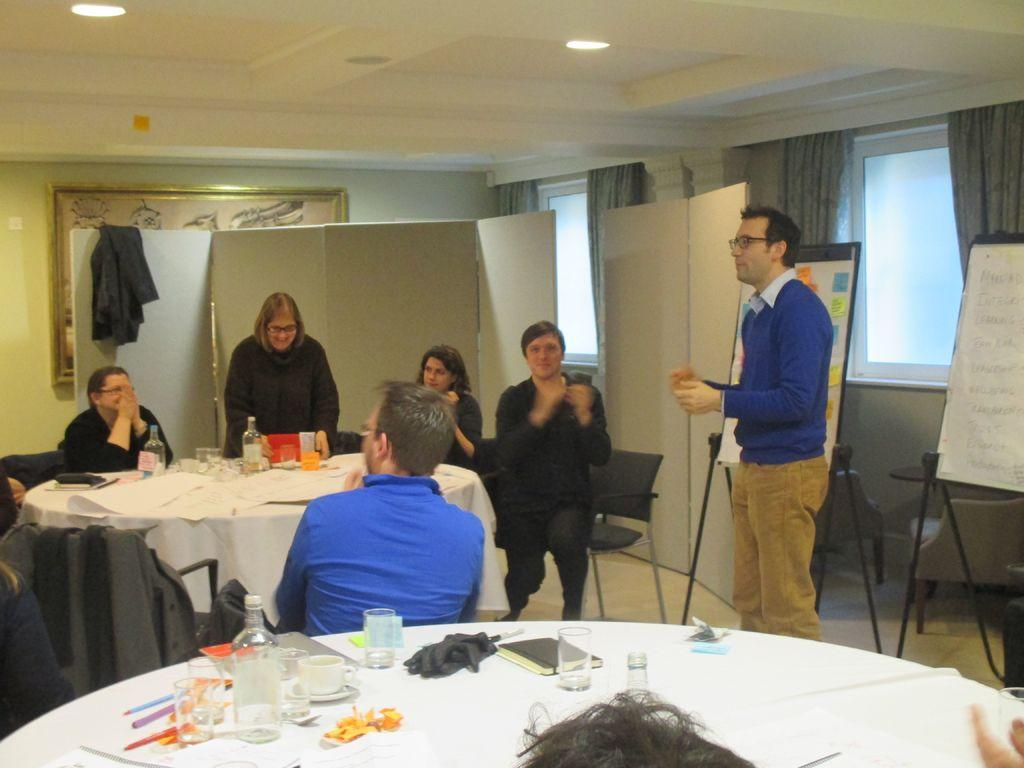How many tables are visible in the image? There are two tables in the image. What is covering the tables? The tables are covered with cloth. What objects can be seen on the tables? There are glasses on the tables. Can you describe the man in the image? There is a man in blue standing in the image. What color is the roof top in the image? The roof top is in white color. What type of quiver is the man holding in the image? There is no quiver present in the image; the man is simply standing in blue clothing. 